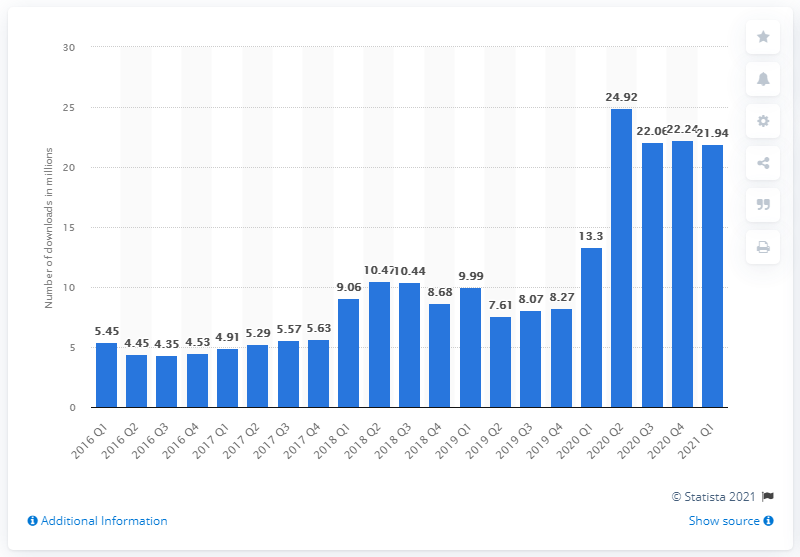Point out several critical features in this image. In the first quarter of 2021, the Twitch live streaming app generated a total of 21.94 downloads. 